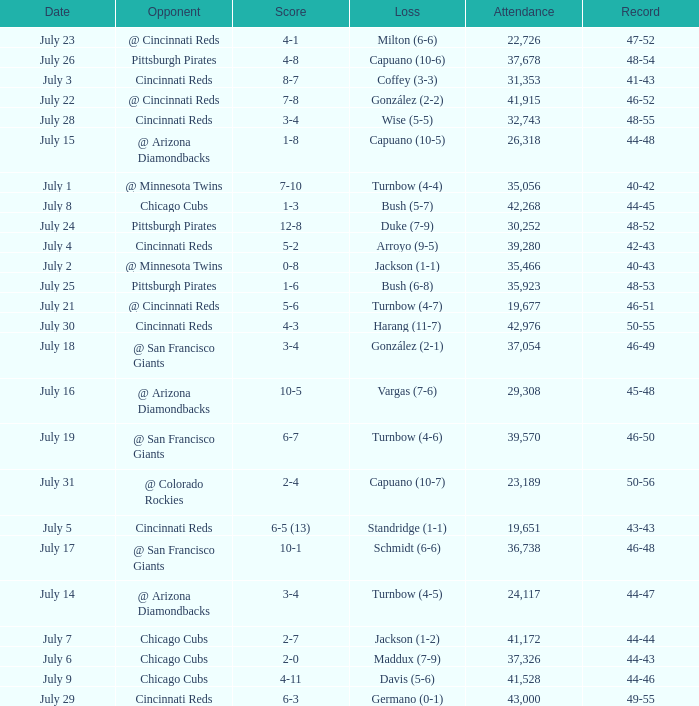What was the record at the game that had a score of 7-10? 40-42. 